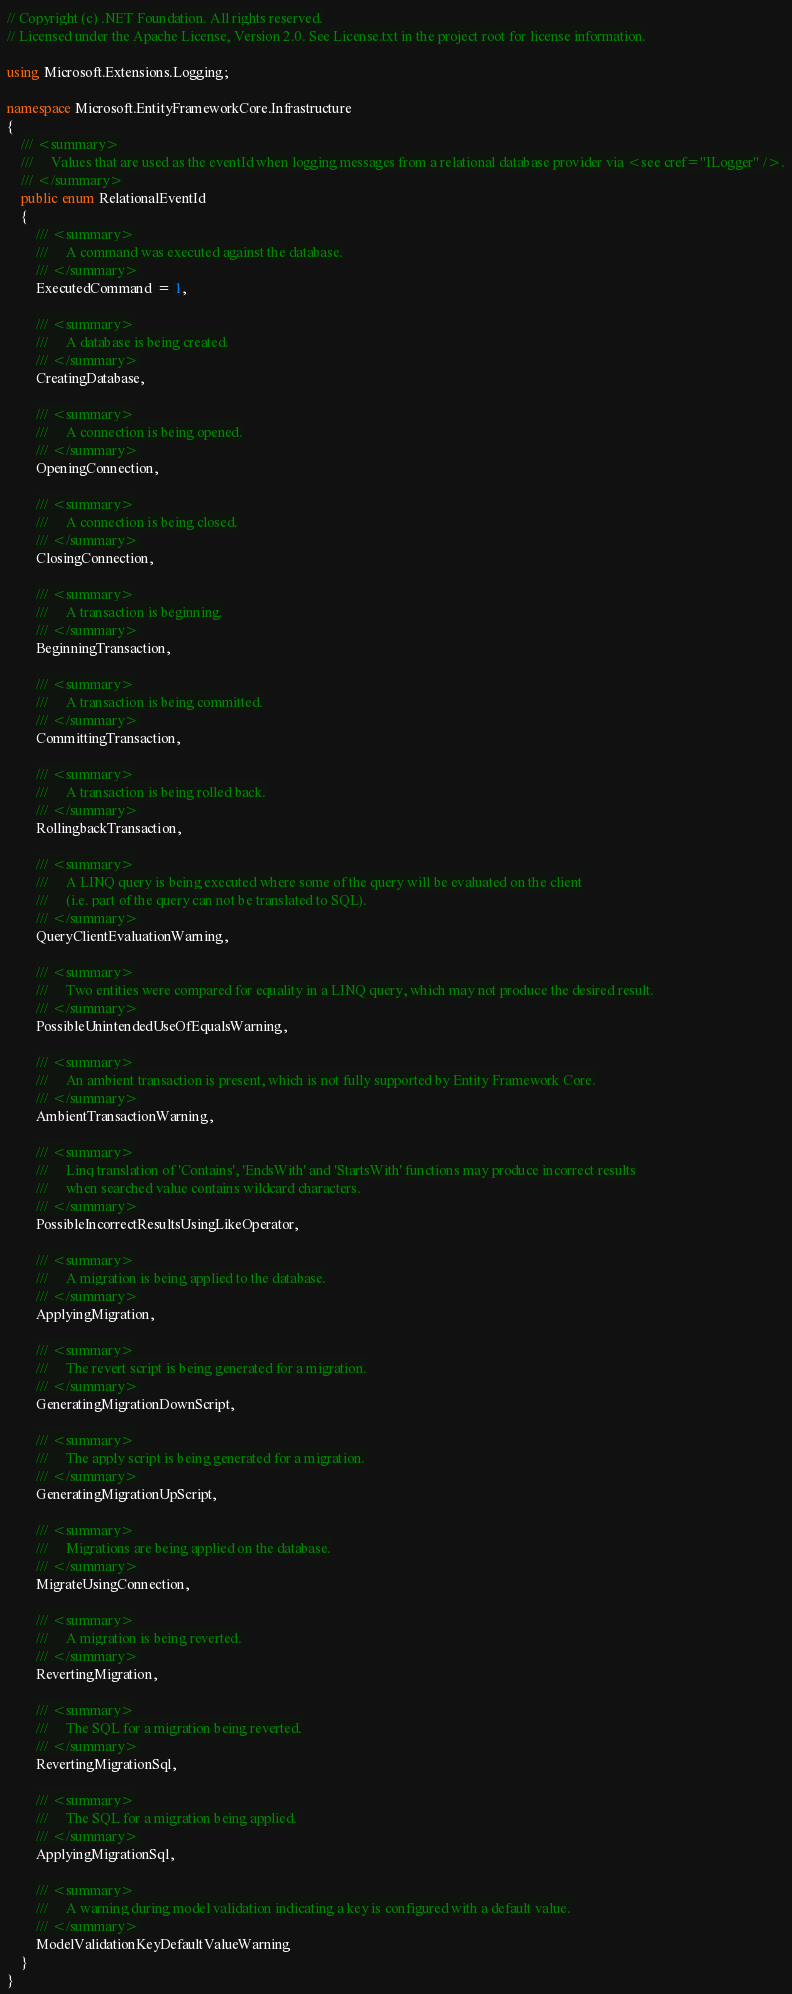<code> <loc_0><loc_0><loc_500><loc_500><_C#_>// Copyright (c) .NET Foundation. All rights reserved.
// Licensed under the Apache License, Version 2.0. See License.txt in the project root for license information.

using Microsoft.Extensions.Logging;

namespace Microsoft.EntityFrameworkCore.Infrastructure
{
    /// <summary>
    ///     Values that are used as the eventId when logging messages from a relational database provider via <see cref="ILogger" />.
    /// </summary>
    public enum RelationalEventId
    {
        /// <summary>
        ///     A command was executed against the database.
        /// </summary>
        ExecutedCommand = 1,

        /// <summary>
        ///     A database is being created.
        /// </summary>
        CreatingDatabase,

        /// <summary>
        ///     A connection is being opened.
        /// </summary>
        OpeningConnection,

        /// <summary>
        ///     A connection is being closed.
        /// </summary>
        ClosingConnection,

        /// <summary>
        ///     A transaction is beginning.
        /// </summary>
        BeginningTransaction,

        /// <summary>
        ///     A transaction is being committed.
        /// </summary>
        CommittingTransaction,

        /// <summary>
        ///     A transaction is being rolled back.
        /// </summary>
        RollingbackTransaction,

        /// <summary>
        ///     A LINQ query is being executed where some of the query will be evaluated on the client
        ///     (i.e. part of the query can not be translated to SQL).
        /// </summary>
        QueryClientEvaluationWarning,

        /// <summary>
        ///     Two entities were compared for equality in a LINQ query, which may not produce the desired result.
        /// </summary>
        PossibleUnintendedUseOfEqualsWarning,

        /// <summary>
        ///     An ambient transaction is present, which is not fully supported by Entity Framework Core.
        /// </summary>
        AmbientTransactionWarning,

        /// <summary>
        ///     Linq translation of 'Contains', 'EndsWith' and 'StartsWith' functions may produce incorrect results
        ///     when searched value contains wildcard characters.
        /// </summary>
        PossibleIncorrectResultsUsingLikeOperator,

        /// <summary>
        ///     A migration is being applied to the database.
        /// </summary>
        ApplyingMigration,

        /// <summary>
        ///     The revert script is being generated for a migration.
        /// </summary>
        GeneratingMigrationDownScript,

        /// <summary>
        ///     The apply script is being generated for a migration.
        /// </summary>
        GeneratingMigrationUpScript,

        /// <summary>
        ///     Migrations are being applied on the database.
        /// </summary>
        MigrateUsingConnection,

        /// <summary>
        ///     A migration is being reverted.
        /// </summary>
        RevertingMigration,

        /// <summary>
        ///     The SQL for a migration being reverted.
        /// </summary>
        RevertingMigrationSql,

        /// <summary>
        ///     The SQL for a migration being applied.
        /// </summary>
        ApplyingMigrationSql,

        /// <summary>
        ///     A warning during model validation indicating a key is configured with a default value.
        /// </summary>
        ModelValidationKeyDefaultValueWarning
    }
}
</code> 